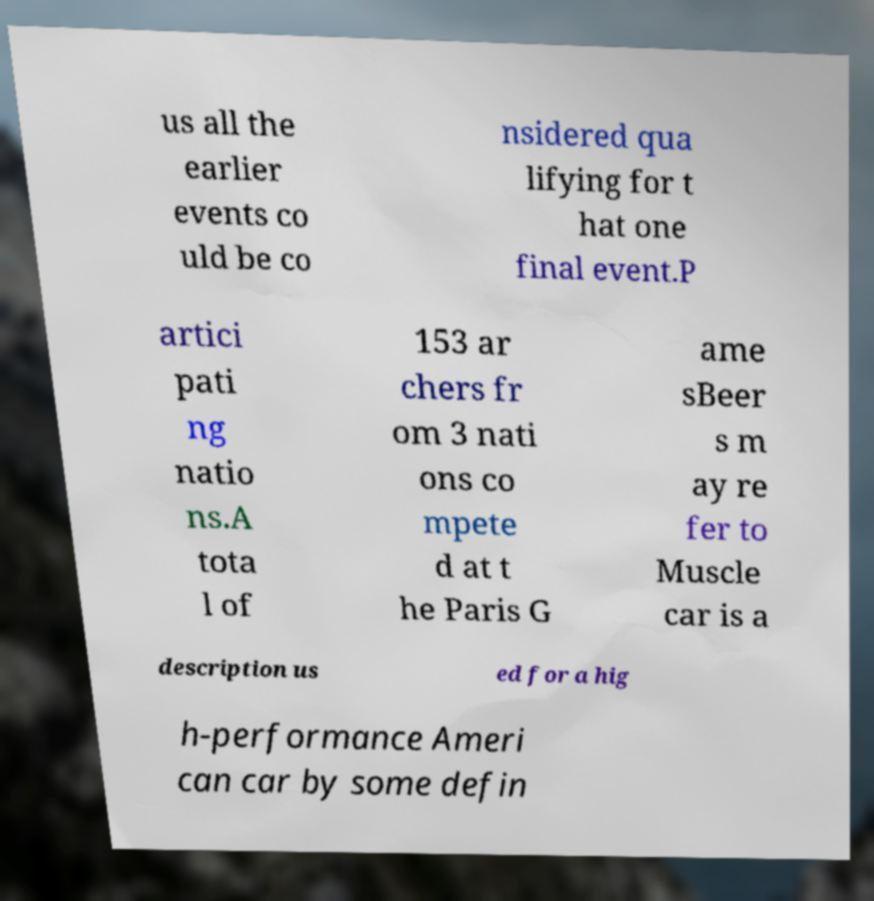There's text embedded in this image that I need extracted. Can you transcribe it verbatim? us all the earlier events co uld be co nsidered qua lifying for t hat one final event.P artici pati ng natio ns.A tota l of 153 ar chers fr om 3 nati ons co mpete d at t he Paris G ame sBeer s m ay re fer to Muscle car is a description us ed for a hig h-performance Ameri can car by some defin 